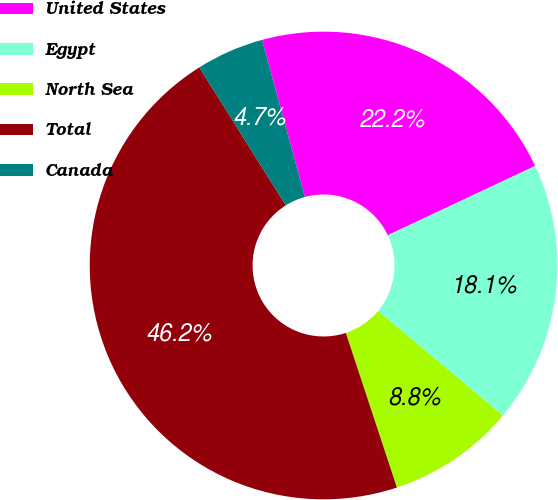<chart> <loc_0><loc_0><loc_500><loc_500><pie_chart><fcel>United States<fcel>Egypt<fcel>North Sea<fcel>Total<fcel>Canada<nl><fcel>22.24%<fcel>18.09%<fcel>8.83%<fcel>46.16%<fcel>4.68%<nl></chart> 